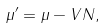Convert formula to latex. <formula><loc_0><loc_0><loc_500><loc_500>\mu ^ { \prime } = \mu - V N ,</formula> 